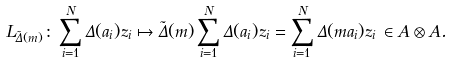Convert formula to latex. <formula><loc_0><loc_0><loc_500><loc_500>L _ { \tilde { \Delta } ( m ) } \colon \sum _ { i = 1 } ^ { N } \Delta ( a _ { i } ) z _ { i } \mapsto \tilde { \Delta } ( m ) \sum _ { i = 1 } ^ { N } \Delta ( a _ { i } ) z _ { i } = \sum _ { i = 1 } ^ { N } \Delta ( m a _ { i } ) z _ { i } \, \in A \otimes A .</formula> 